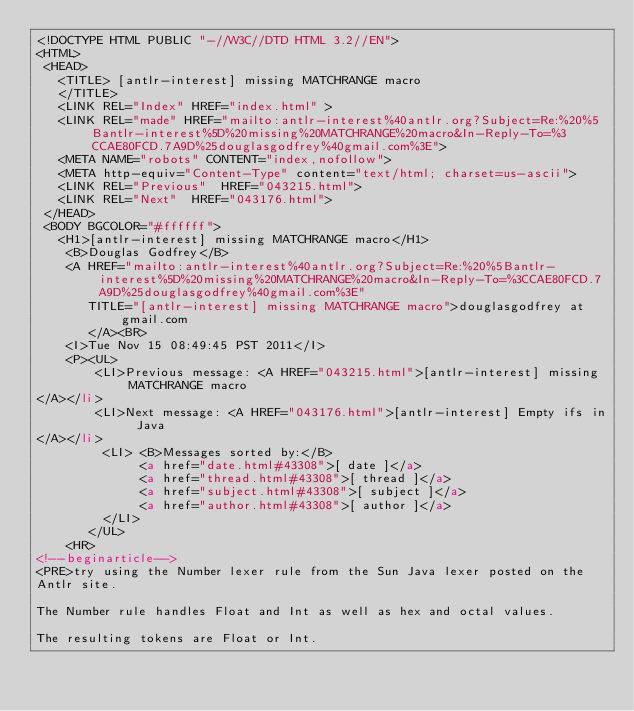Convert code to text. <code><loc_0><loc_0><loc_500><loc_500><_HTML_><!DOCTYPE HTML PUBLIC "-//W3C//DTD HTML 3.2//EN">
<HTML>
 <HEAD>
   <TITLE> [antlr-interest] missing MATCHRANGE macro
   </TITLE>
   <LINK REL="Index" HREF="index.html" >
   <LINK REL="made" HREF="mailto:antlr-interest%40antlr.org?Subject=Re:%20%5Bantlr-interest%5D%20missing%20MATCHRANGE%20macro&In-Reply-To=%3CCAE80FCD.7A9D%25douglasgodfrey%40gmail.com%3E">
   <META NAME="robots" CONTENT="index,nofollow">
   <META http-equiv="Content-Type" content="text/html; charset=us-ascii">
   <LINK REL="Previous"  HREF="043215.html">
   <LINK REL="Next"  HREF="043176.html">
 </HEAD>
 <BODY BGCOLOR="#ffffff">
   <H1>[antlr-interest] missing MATCHRANGE macro</H1>
    <B>Douglas Godfrey</B> 
    <A HREF="mailto:antlr-interest%40antlr.org?Subject=Re:%20%5Bantlr-interest%5D%20missing%20MATCHRANGE%20macro&In-Reply-To=%3CCAE80FCD.7A9D%25douglasgodfrey%40gmail.com%3E"
       TITLE="[antlr-interest] missing MATCHRANGE macro">douglasgodfrey at gmail.com
       </A><BR>
    <I>Tue Nov 15 08:49:45 PST 2011</I>
    <P><UL>
        <LI>Previous message: <A HREF="043215.html">[antlr-interest] missing MATCHRANGE macro
</A></li>
        <LI>Next message: <A HREF="043176.html">[antlr-interest] Empty ifs in Java
</A></li>
         <LI> <B>Messages sorted by:</B> 
              <a href="date.html#43308">[ date ]</a>
              <a href="thread.html#43308">[ thread ]</a>
              <a href="subject.html#43308">[ subject ]</a>
              <a href="author.html#43308">[ author ]</a>
         </LI>
       </UL>
    <HR>  
<!--beginarticle-->
<PRE>try using the Number lexer rule from the Sun Java lexer posted on the
Antlr site.

The Number rule handles Float and Int as well as hex and octal values.

The resulting tokens are Float or Int.



</code> 